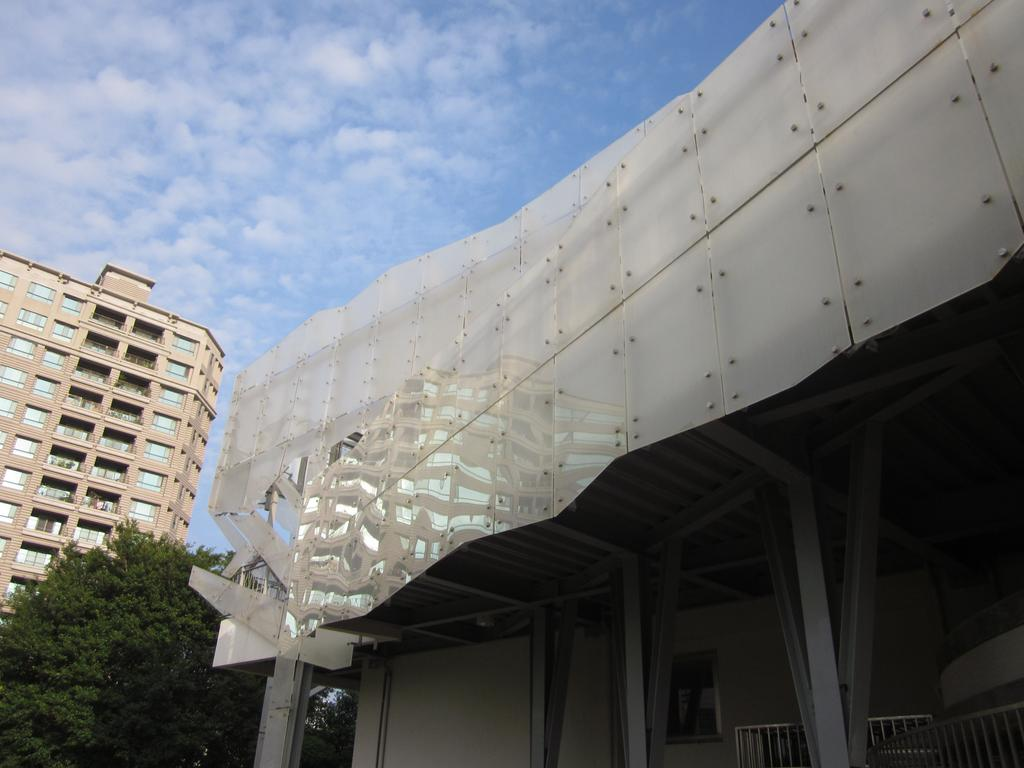What type of structures can be seen in the image? There are buildings in the image. What other natural elements are present in the image? There are trees in the image. What feature can be seen on the buildings or structures? Railings are visible in the image. What is visible in the sky in the image? Clouds are present in the sky in the image. What type of shoes can be seen hanging from the trees in the image? There are no shoes hanging from the trees in the image; only buildings, trees, railings, and clouds are present. 